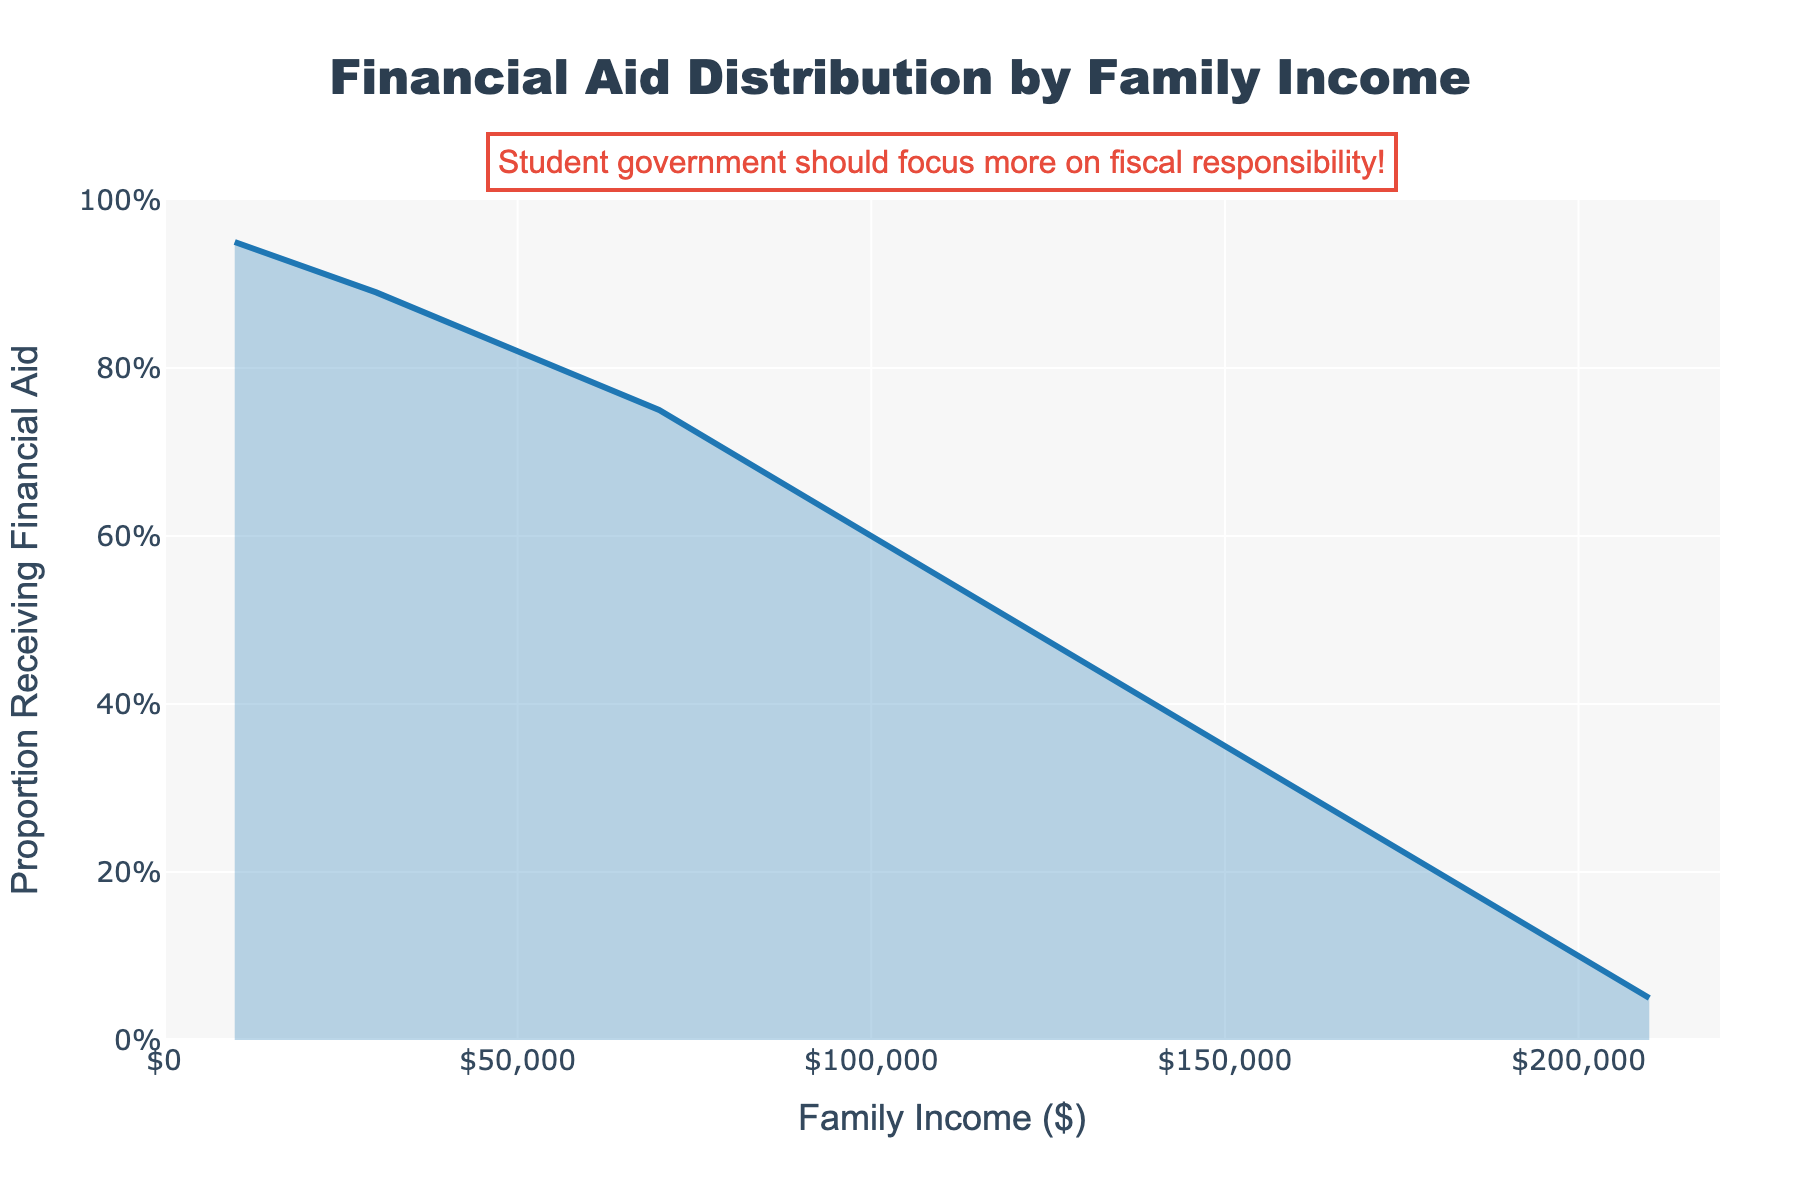what is the title of the plot? The title of the plot is displayed at the top and is most often used to provide a quick idea of what the graph represents. Here, the title says, "Financial Aid Distribution by Family Income."
Answer: Financial Aid Distribution by Family Income What does the x-axis represent? The x-axis is labeled and it shows "Family Income ($)". This suggests that it represents various income brackets in dollars.
Answer: Family Income ($) What is the y-axis range? By observing the graph, the y-axis is labeled "Proportion Receiving Financial Aid," and it ranges from 0 to 1.
Answer: 0 to 1 Which income bracket has the highest proportion of students receiving financial aid? By looking at the density curve, the highest point occurs at the "0-20000" income bracket, where the proportion is 0.95.
Answer: 0-20000 Which income bracket has the lowest proportion of students receiving financial aid? By observing the graph, the lowest point on the curve is at the "200001+" income bracket, where the proportion is 0.05.
Answer: 200001+ Describe the trend of financial aid as family income increases. The curve shows a decreasing trend, indicating that as family income increases, the proportion of students receiving financial aid decreases.
Answer: Decreasing What is the approximate proportion of students receiving financial aid in the 80,001-100,000 income bracket? By locating the $80,001-$100,000 income bracket on the x-axis and checking the corresponding point on the density plot, the proportion is around 0.65.
Answer: 0.65 How much larger is the proportion of students receiving financial aid in the 0-20,000 income bracket compared to the 100,001-120,000 income bracket? Subtract the proportion of students in the 100,001-120,000 bracket (0.55) from the proportion in the 0-20,000 bracket (0.95). The difference is 0.95 - 0.55 = 0.40.
Answer: 0.40 In which family income bracket does the proportion receiving financial aid drop below 0.5? By examining the density plot, the proportion drops below 0.5 after the 100,001-120,000 income bracket. The next bracket, 120,001-140,000, has a proportion of 0.45, which is below 0.5.
Answer: 120001-140000 Why might the annotation suggest that the student government should focus more on fiscal responsibility? The annotation likely believes that focusing on fiscal responsibility could ensure more efficient allocation of financial aid resources, perhaps ensuring those in need receive adequate support. This suggestion stems from the various aid proportions depicted and advocating for careful financial oversight.
Answer: Efficient allocation of financial aid 